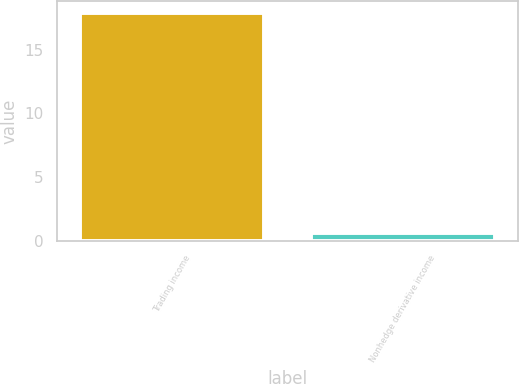Convert chart. <chart><loc_0><loc_0><loc_500><loc_500><bar_chart><fcel>Trading income<fcel>Nonhedge derivative income<nl><fcel>17.9<fcel>0.6<nl></chart> 